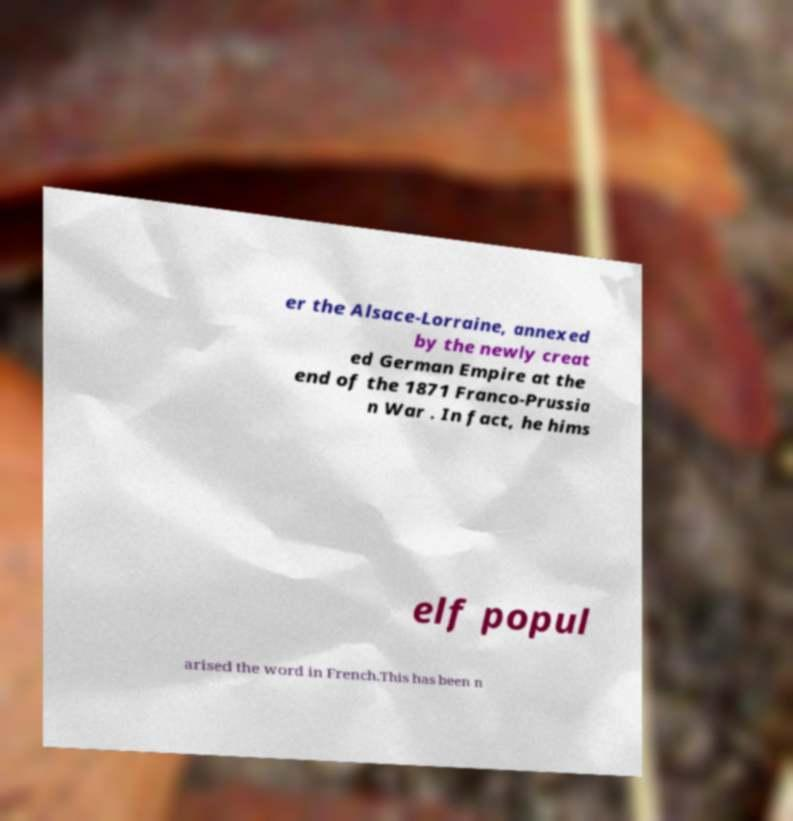For documentation purposes, I need the text within this image transcribed. Could you provide that? er the Alsace-Lorraine, annexed by the newly creat ed German Empire at the end of the 1871 Franco-Prussia n War . In fact, he hims elf popul arised the word in French.This has been n 